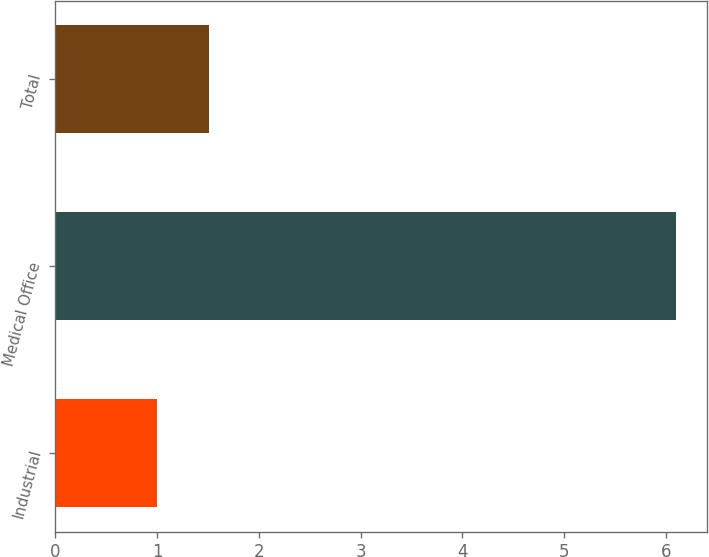<chart> <loc_0><loc_0><loc_500><loc_500><bar_chart><fcel>Industrial<fcel>Medical Office<fcel>Total<nl><fcel>1<fcel>6.1<fcel>1.51<nl></chart> 